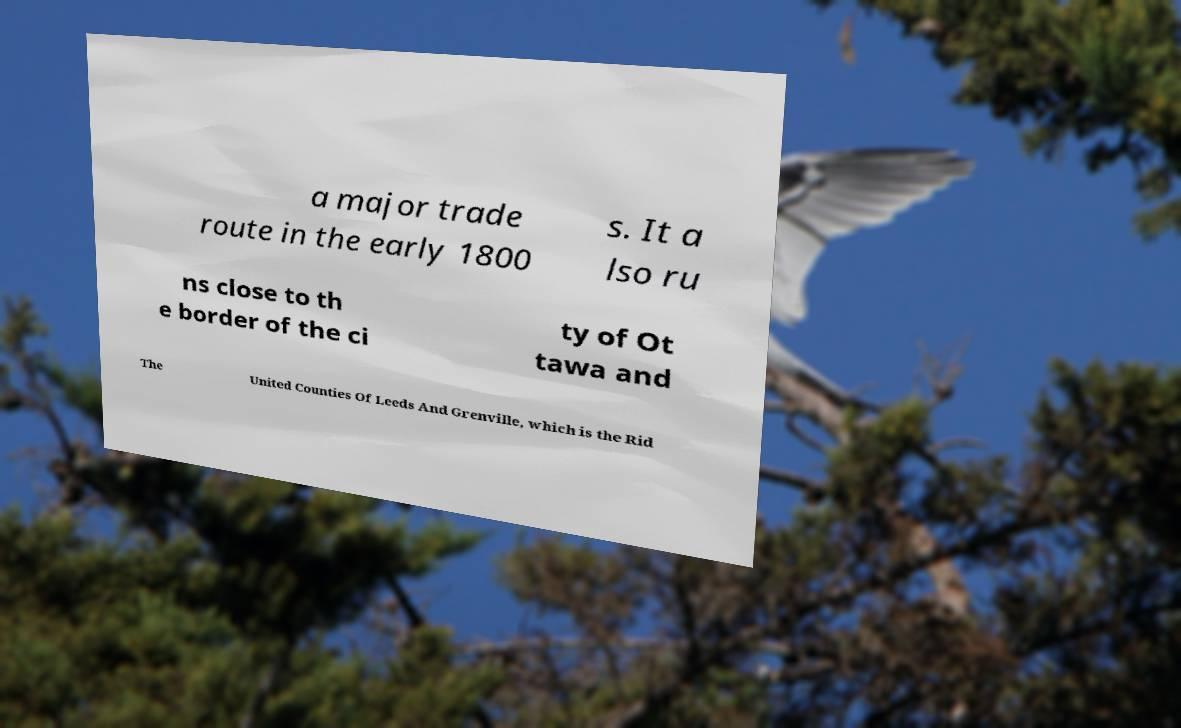Could you extract and type out the text from this image? a major trade route in the early 1800 s. It a lso ru ns close to th e border of the ci ty of Ot tawa and The United Counties Of Leeds And Grenville, which is the Rid 